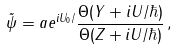<formula> <loc_0><loc_0><loc_500><loc_500>\tilde { \psi } = a e ^ { i U _ { 0 } / } \frac { \Theta ( { Y } + i { U } / \hbar { ) } } { \Theta ( { Z } + i { U } / \hbar { ) } } \, ,</formula> 